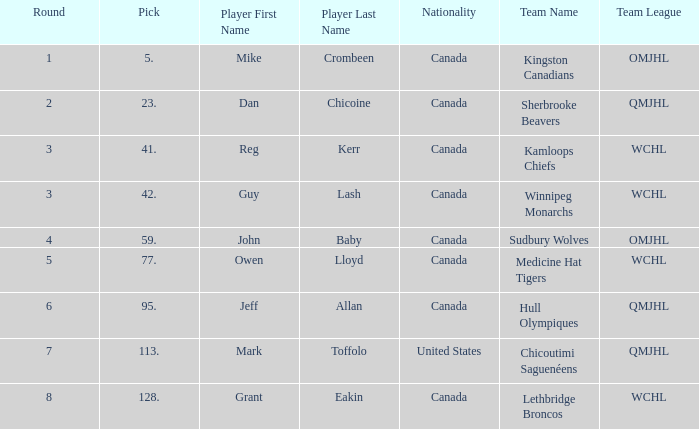Which Round has a Player of dan chicoine, and a Pick larger than 23? None. 